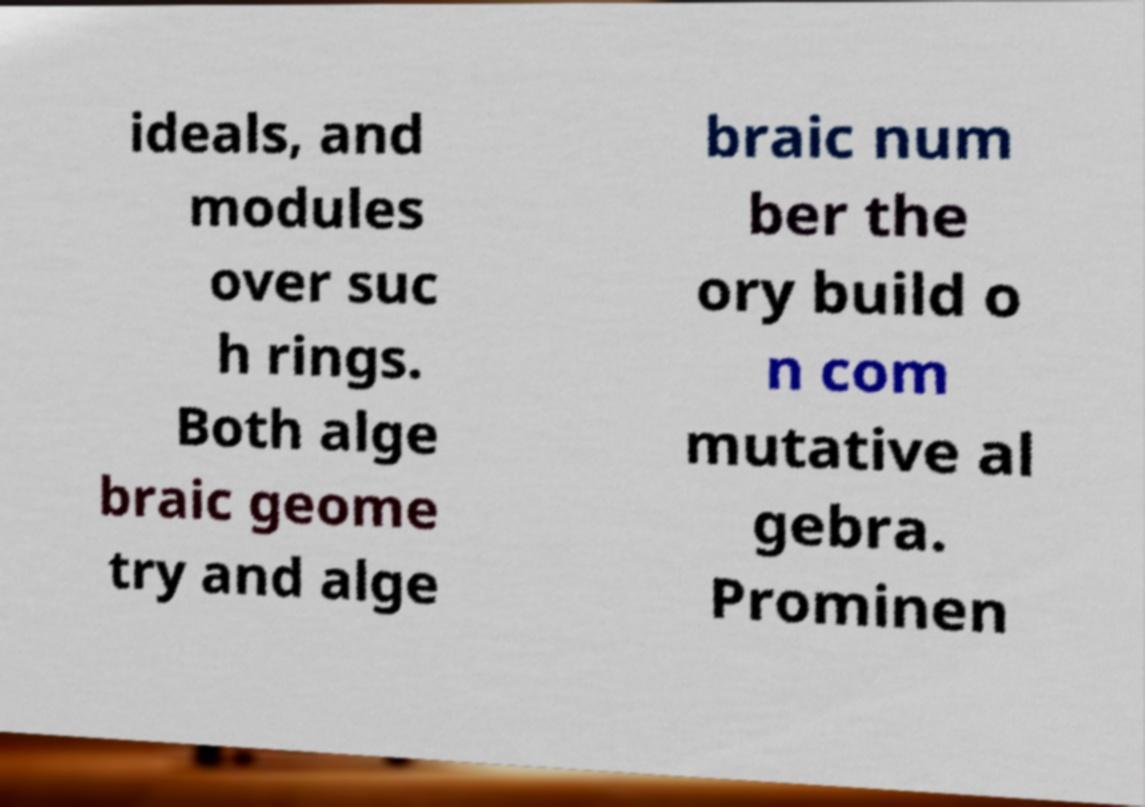Could you extract and type out the text from this image? ideals, and modules over suc h rings. Both alge braic geome try and alge braic num ber the ory build o n com mutative al gebra. Prominen 